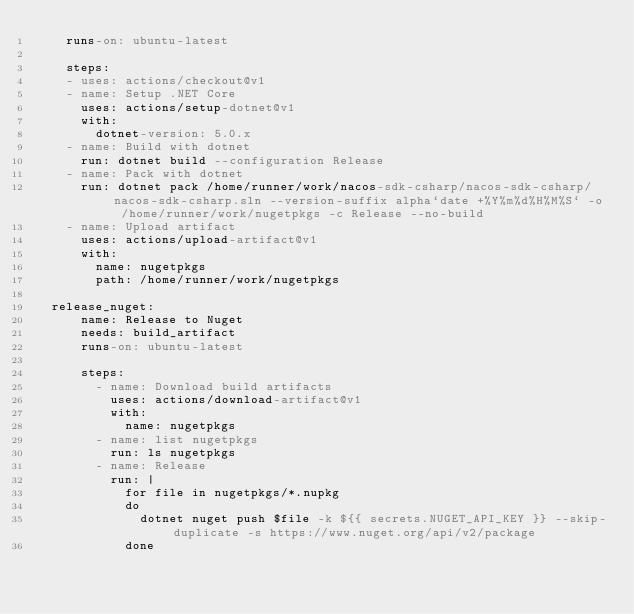Convert code to text. <code><loc_0><loc_0><loc_500><loc_500><_YAML_>    runs-on: ubuntu-latest
    
    steps:
    - uses: actions/checkout@v1
    - name: Setup .NET Core
      uses: actions/setup-dotnet@v1
      with:
        dotnet-version: 5.0.x
    - name: Build with dotnet
      run: dotnet build --configuration Release
    - name: Pack with dotnet
      run: dotnet pack /home/runner/work/nacos-sdk-csharp/nacos-sdk-csharp/nacos-sdk-csharp.sln --version-suffix alpha`date +%Y%m%d%H%M%S` -o /home/runner/work/nugetpkgs -c Release --no-build
    - name: Upload artifact
      uses: actions/upload-artifact@v1
      with:
        name: nugetpkgs
        path: /home/runner/work/nugetpkgs  

  release_nuget:
      name: Release to Nuget
      needs: build_artifact
      runs-on: ubuntu-latest
  
      steps:
        - name: Download build artifacts
          uses: actions/download-artifact@v1
          with:
            name: nugetpkgs
        - name: list nugetpkgs
          run: ls nugetpkgs
        - name: Release
          run: |
            for file in nugetpkgs/*.nupkg
            do
              dotnet nuget push $file -k ${{ secrets.NUGET_API_KEY }} --skip-duplicate -s https://www.nuget.org/api/v2/package
            done</code> 